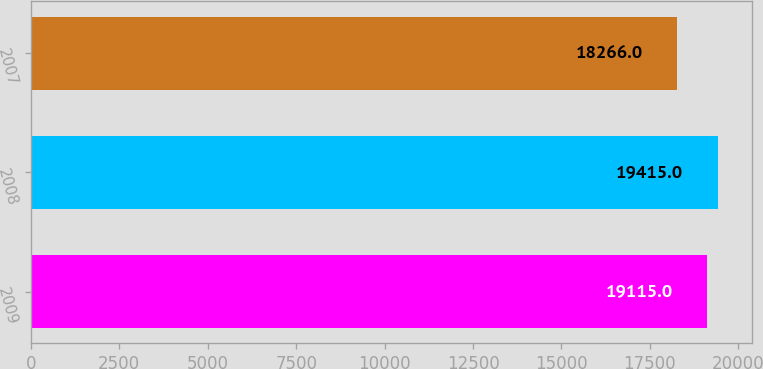Convert chart. <chart><loc_0><loc_0><loc_500><loc_500><bar_chart><fcel>2009<fcel>2008<fcel>2007<nl><fcel>19115<fcel>19415<fcel>18266<nl></chart> 